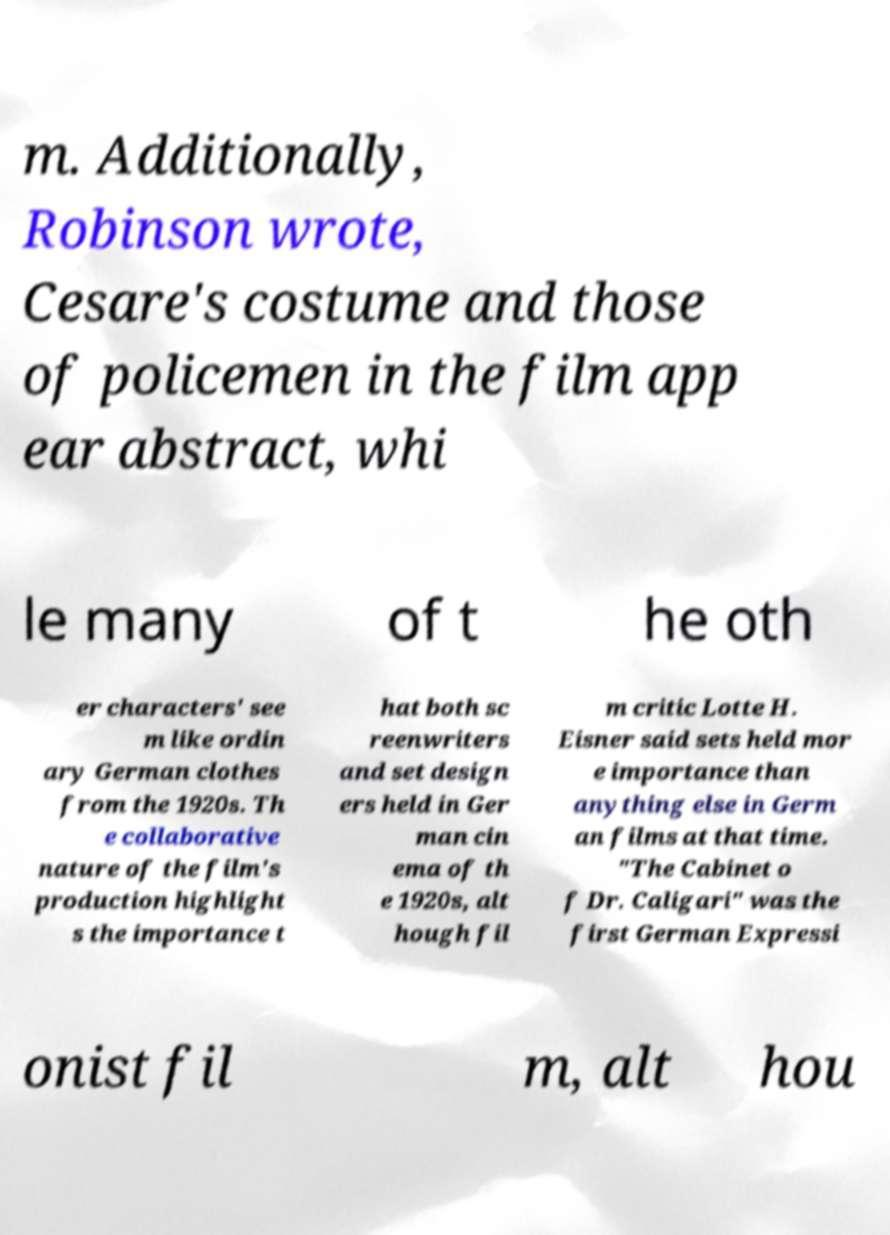Can you accurately transcribe the text from the provided image for me? m. Additionally, Robinson wrote, Cesare's costume and those of policemen in the film app ear abstract, whi le many of t he oth er characters' see m like ordin ary German clothes from the 1920s. Th e collaborative nature of the film's production highlight s the importance t hat both sc reenwriters and set design ers held in Ger man cin ema of th e 1920s, alt hough fil m critic Lotte H. Eisner said sets held mor e importance than anything else in Germ an films at that time. "The Cabinet o f Dr. Caligari" was the first German Expressi onist fil m, alt hou 